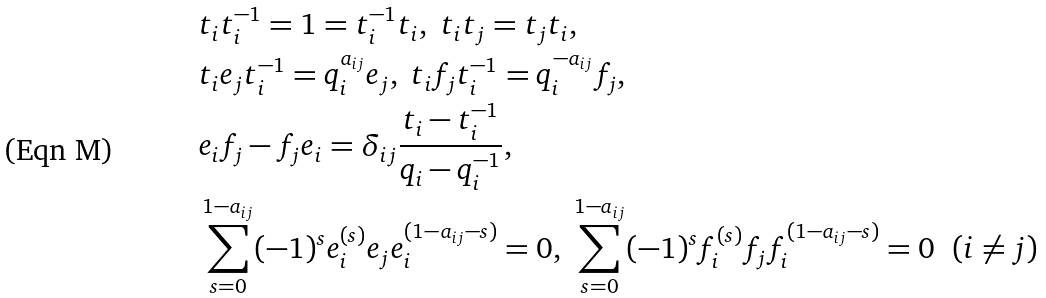Convert formula to latex. <formula><loc_0><loc_0><loc_500><loc_500>& t _ { i } t _ { i } ^ { - 1 } = 1 = t _ { i } ^ { - 1 } t _ { i } , \ t _ { i } t _ { j } = t _ { j } t _ { i } , \\ & t _ { i } e _ { j } t _ { i } ^ { - 1 } = q _ { i } ^ { a _ { i j } } e _ { j } , \ t _ { i } f _ { j } t _ { i } ^ { - 1 } = q _ { i } ^ { - a _ { i j } } f _ { j } , \\ & e _ { i } f _ { j } - f _ { j } e _ { i } = \delta _ { i j } \frac { t _ { i } - t _ { i } ^ { - 1 } } { q _ { i } - q _ { i } ^ { - 1 } } , \\ & \sum _ { s = 0 } ^ { 1 - a _ { i j } } ( - 1 ) ^ { s } e _ { i } ^ { ( s ) } e _ { j } e _ { i } ^ { ( 1 - a _ { i j } - s ) } = 0 , \ \sum _ { s = 0 } ^ { 1 - a _ { i j } } ( - 1 ) ^ { s } f _ { i } ^ { ( s ) } f _ { j } f _ { i } ^ { ( 1 - a _ { i j } - s ) } = 0 \ \ ( i \ne j )</formula> 